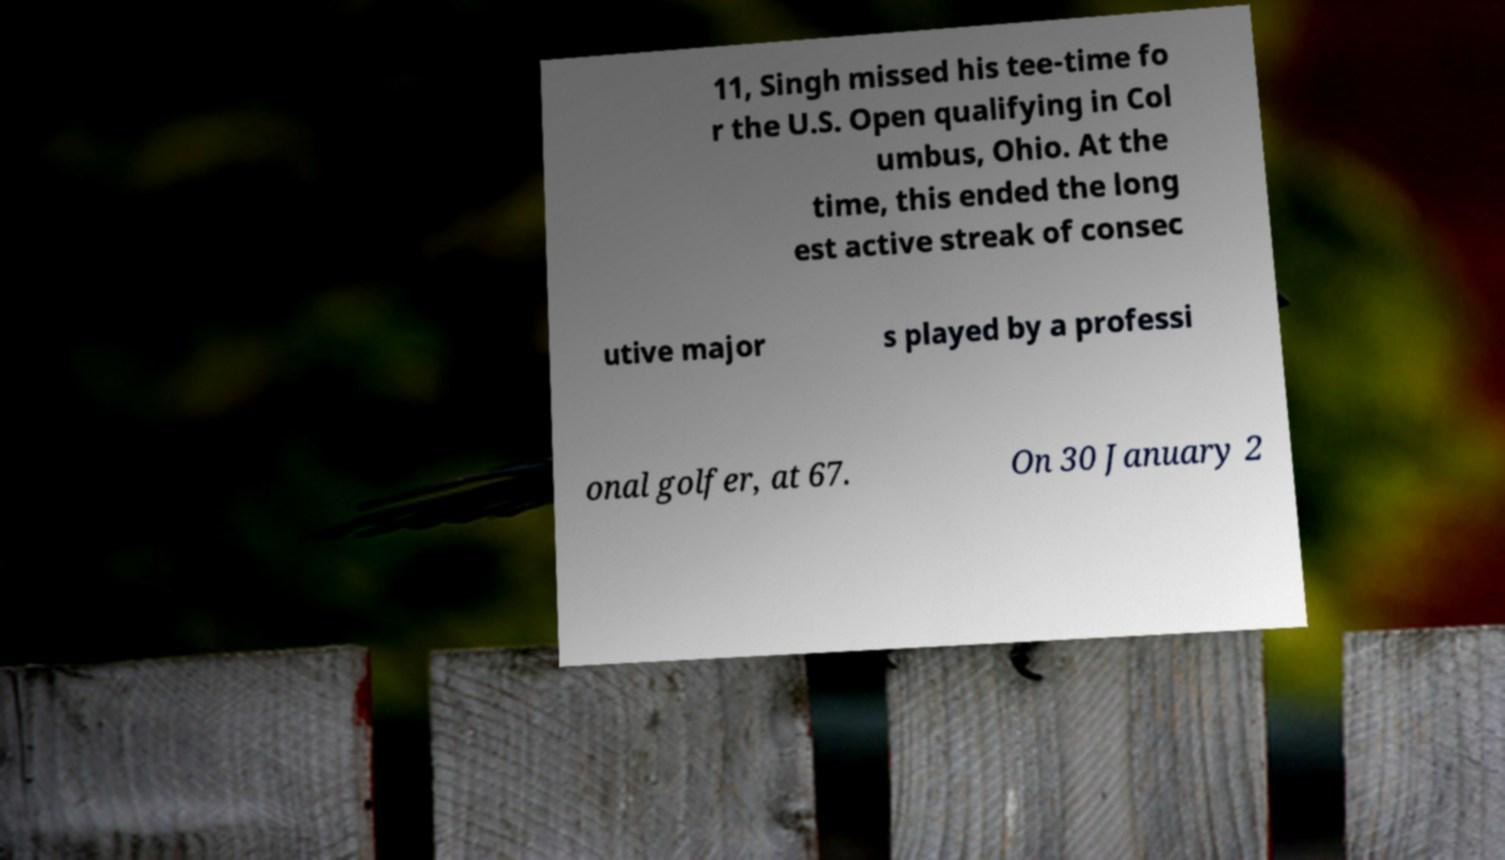There's text embedded in this image that I need extracted. Can you transcribe it verbatim? 11, Singh missed his tee-time fo r the U.S. Open qualifying in Col umbus, Ohio. At the time, this ended the long est active streak of consec utive major s played by a professi onal golfer, at 67. On 30 January 2 